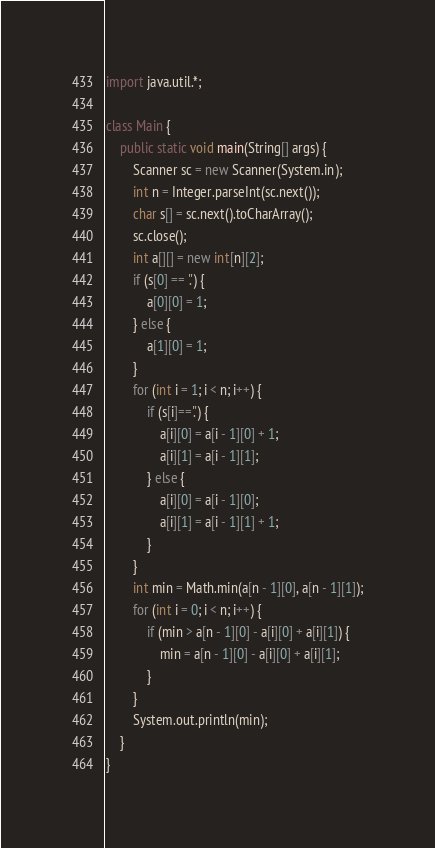Convert code to text. <code><loc_0><loc_0><loc_500><loc_500><_Java_>import java.util.*;

class Main {
    public static void main(String[] args) {
        Scanner sc = new Scanner(System.in);
        int n = Integer.parseInt(sc.next());
        char s[] = sc.next().toCharArray();
        sc.close();
        int a[][] = new int[n][2];
        if (s[0] == '.') {
            a[0][0] = 1;
        } else {
            a[1][0] = 1;
        }
        for (int i = 1; i < n; i++) {
            if (s[i]=='.') {
                a[i][0] = a[i - 1][0] + 1;
                a[i][1] = a[i - 1][1];
            } else {
                a[i][0] = a[i - 1][0];
                a[i][1] = a[i - 1][1] + 1;
            }
        }
        int min = Math.min(a[n - 1][0], a[n - 1][1]);
        for (int i = 0; i < n; i++) {
            if (min > a[n - 1][0] - a[i][0] + a[i][1]) {
                min = a[n - 1][0] - a[i][0] + a[i][1];
            }
        }
        System.out.println(min);
    }
}</code> 